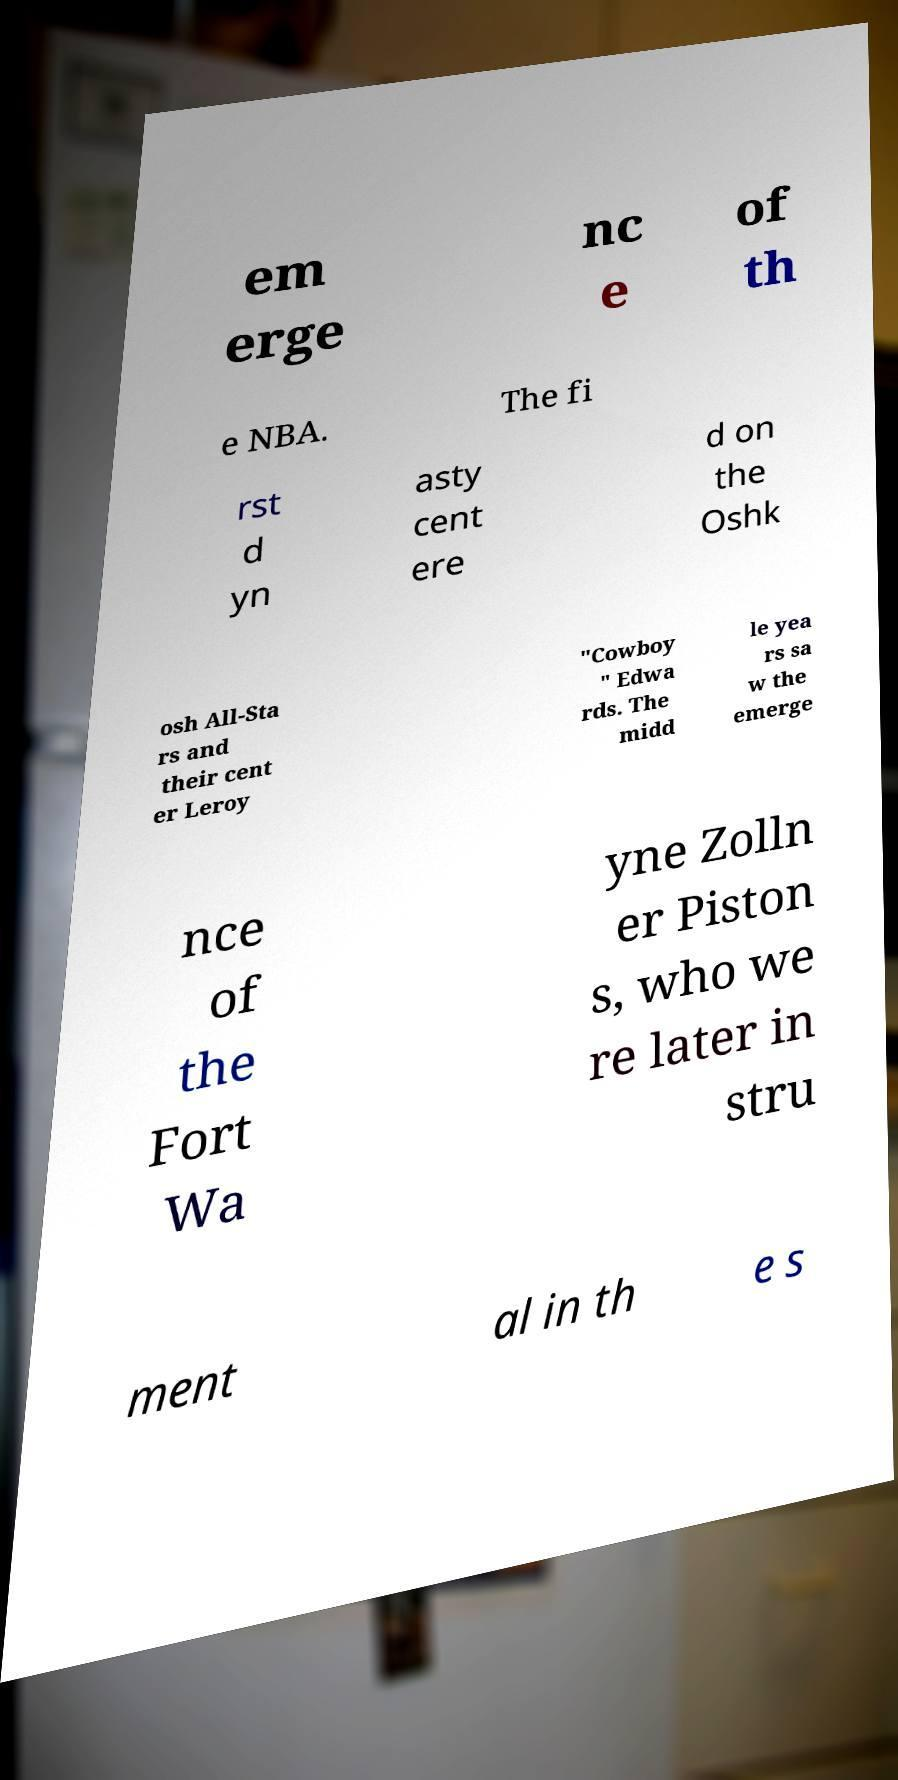Can you accurately transcribe the text from the provided image for me? em erge nc e of th e NBA. The fi rst d yn asty cent ere d on the Oshk osh All-Sta rs and their cent er Leroy "Cowboy " Edwa rds. The midd le yea rs sa w the emerge nce of the Fort Wa yne Zolln er Piston s, who we re later in stru ment al in th e s 